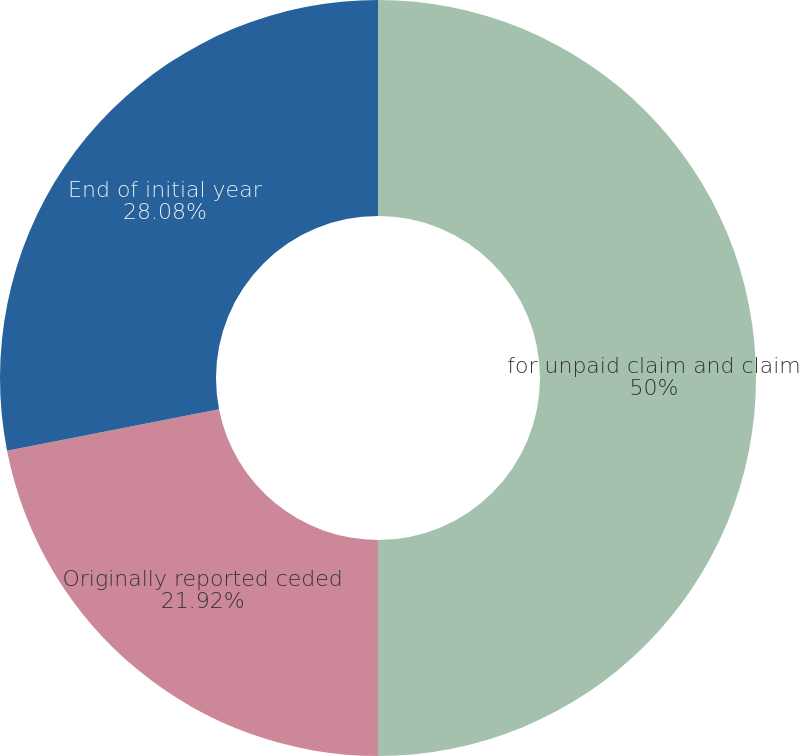<chart> <loc_0><loc_0><loc_500><loc_500><pie_chart><fcel>for unpaid claim and claim<fcel>Originally reported ceded<fcel>End of initial year<nl><fcel>50.0%<fcel>21.92%<fcel>28.08%<nl></chart> 